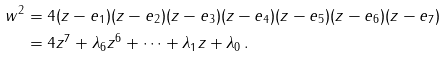<formula> <loc_0><loc_0><loc_500><loc_500>w ^ { 2 } & = 4 ( z - e _ { 1 } ) ( z - e _ { 2 } ) ( z - e _ { 3 } ) ( z - e _ { 4 } ) ( z - e _ { 5 } ) ( z - e _ { 6 } ) ( z - e _ { 7 } ) \\ & = 4 z ^ { 7 } + \lambda _ { 6 } z ^ { 6 } + \dots + \lambda _ { 1 } z + \lambda _ { 0 } \, .</formula> 